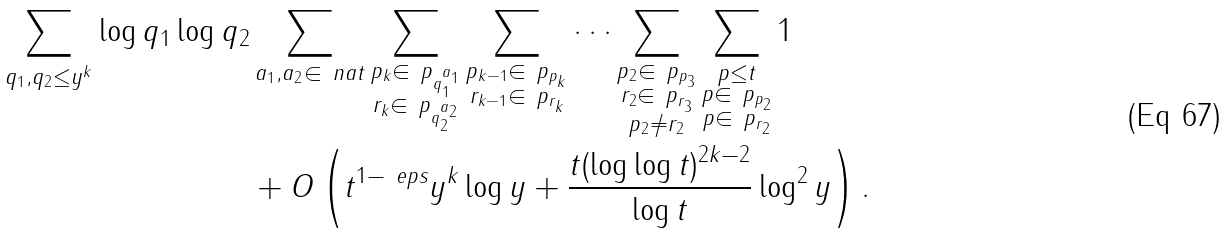Convert formula to latex. <formula><loc_0><loc_0><loc_500><loc_500>\sum _ { q _ { 1 } , q _ { 2 } \leq y ^ { k } } \log q _ { 1 } \log q _ { 2 } & \sum _ { a _ { 1 } , a _ { 2 } \in \ n a t } \sum _ { \substack { p _ { k } \in \ p _ { q _ { 1 } ^ { a _ { 1 } } } \\ r _ { k } \in \ p _ { q _ { 2 } ^ { a _ { 2 } } } } } \sum _ { \substack { p _ { k - 1 } \in \ p _ { p _ { k } } \\ r _ { k - 1 } \in \ p _ { r _ { k } } } } \dots \sum _ { \substack { p _ { 2 } \in \ p _ { p _ { 3 } } \\ r _ { 2 } \in \ p _ { r _ { 3 } } \\ p _ { 2 } \ne r _ { 2 } } } \sum _ { \substack { p \leq t \\ p \in \ p _ { p _ { 2 } } \\ p \in \ p _ { r _ { 2 } } } } 1 \\ & + O \left ( t ^ { 1 - \ e p s } y ^ { k } \log y + \frac { t ( \log \log t ) ^ { 2 k - 2 } } { \log t } \log ^ { 2 } y \right ) .</formula> 